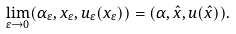Convert formula to latex. <formula><loc_0><loc_0><loc_500><loc_500>\lim _ { \varepsilon \to 0 } ( \alpha _ { \varepsilon } , x _ { \varepsilon } , u _ { \varepsilon } ( x _ { \varepsilon } ) ) = ( \alpha , \hat { x } , u ( \hat { x } ) ) .</formula> 